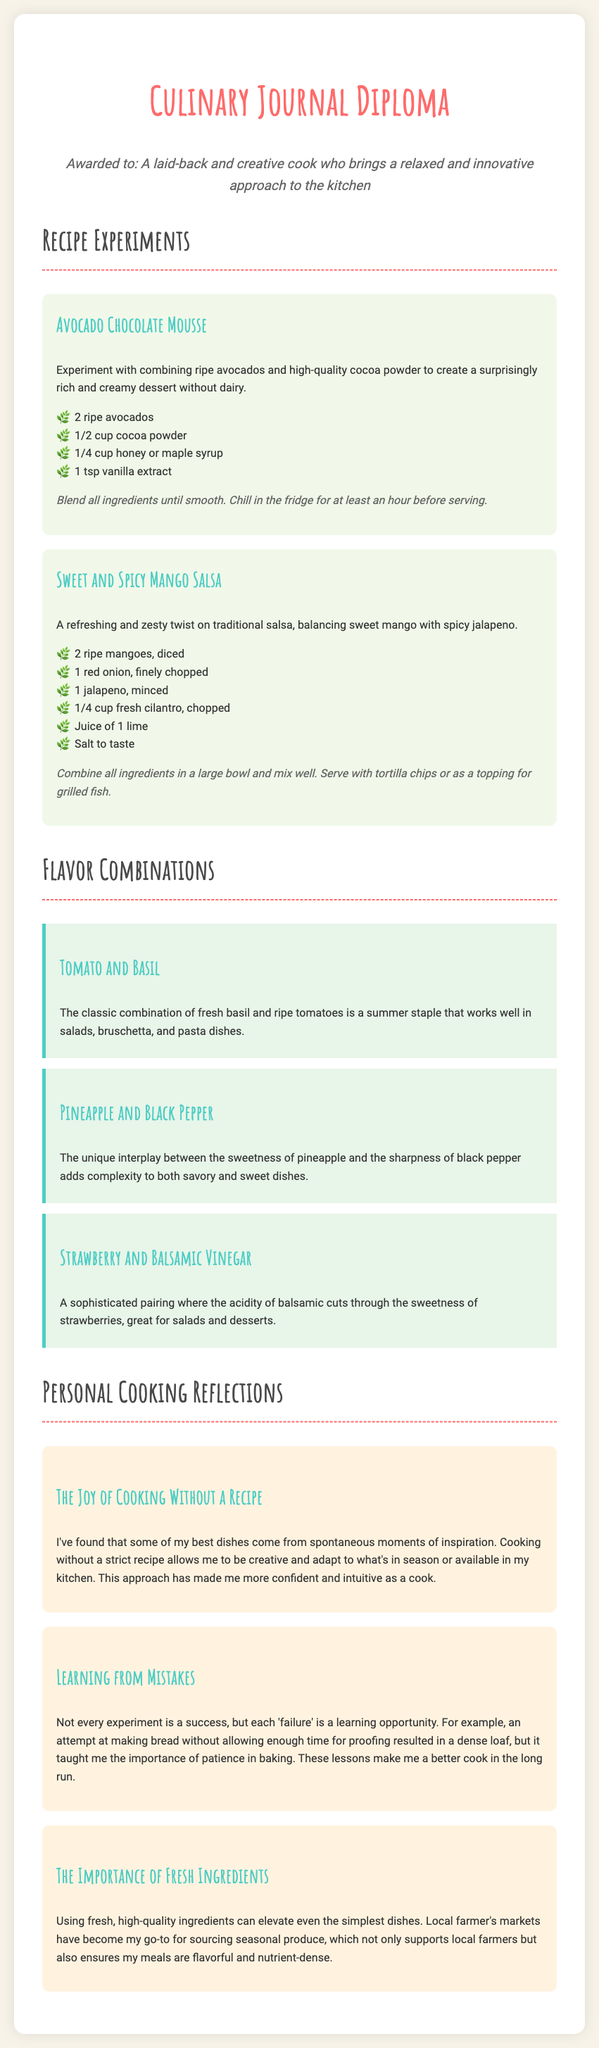What is the name of the diploma? The title of the diploma is stated prominently at the top of the document.
Answer: Culinary Journal Diploma Who is awarded the diploma? The persona section identifies the individual who is awarded the diploma.
Answer: A laid-back and creative cook who brings a relaxed and innovative approach to the kitchen How many recipes are listed in the document? The document contains two recipe entries detailed under the Recipe Experiments section.
Answer: 2 What are the main ingredients in the Avocado Chocolate Mousse? The recipe for Avocado Chocolate Mousse lists specific ingredients, found in the recipe section.
Answer: Ripe avocados, cocoa powder, honey or maple syrup, vanilla extract What flavor combination is highlighted as a summer staple? One of the flavor combinations in the document is described as a summer staple.
Answer: Tomato and Basil What is the tone of the cooking reflections? The reflections share a personal perspective on cooking experiences.
Answer: Joyful and insightful What is the purpose of the Personal Cooking Reflections section? This section reveals the author's thoughts and learning experiences in cooking.
Answer: To share insights and personal growth Which ingredient is emphasized for elevating simple dishes? The reflections detail the importance of high-quality ingredients.
Answer: Fresh ingredients 